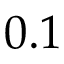Convert formula to latex. <formula><loc_0><loc_0><loc_500><loc_500>0 . 1</formula> 